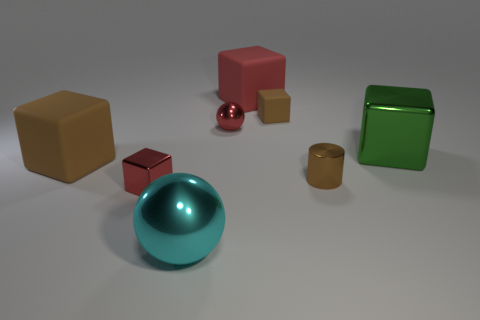Is the brown metallic object the same shape as the big cyan object?
Ensure brevity in your answer.  No. The tiny cube that is the same material as the brown cylinder is what color?
Offer a very short reply. Red. What number of things are balls that are in front of the small cylinder or tiny blue spheres?
Provide a short and direct response. 1. There is a ball that is behind the cyan ball; how big is it?
Your answer should be very brief. Small. Is the size of the red matte thing the same as the red metal ball left of the large green object?
Keep it short and to the point. No. What is the color of the large rubber block in front of the large thing that is right of the tiny brown block?
Offer a very short reply. Brown. How many other things are there of the same color as the tiny shiny sphere?
Provide a short and direct response. 2. The cyan thing is what size?
Make the answer very short. Large. Are there more small brown matte objects in front of the small metallic ball than spheres that are to the left of the red matte block?
Offer a very short reply. No. There is a brown object that is behind the small red shiny ball; what number of rubber blocks are right of it?
Your answer should be very brief. 0. 